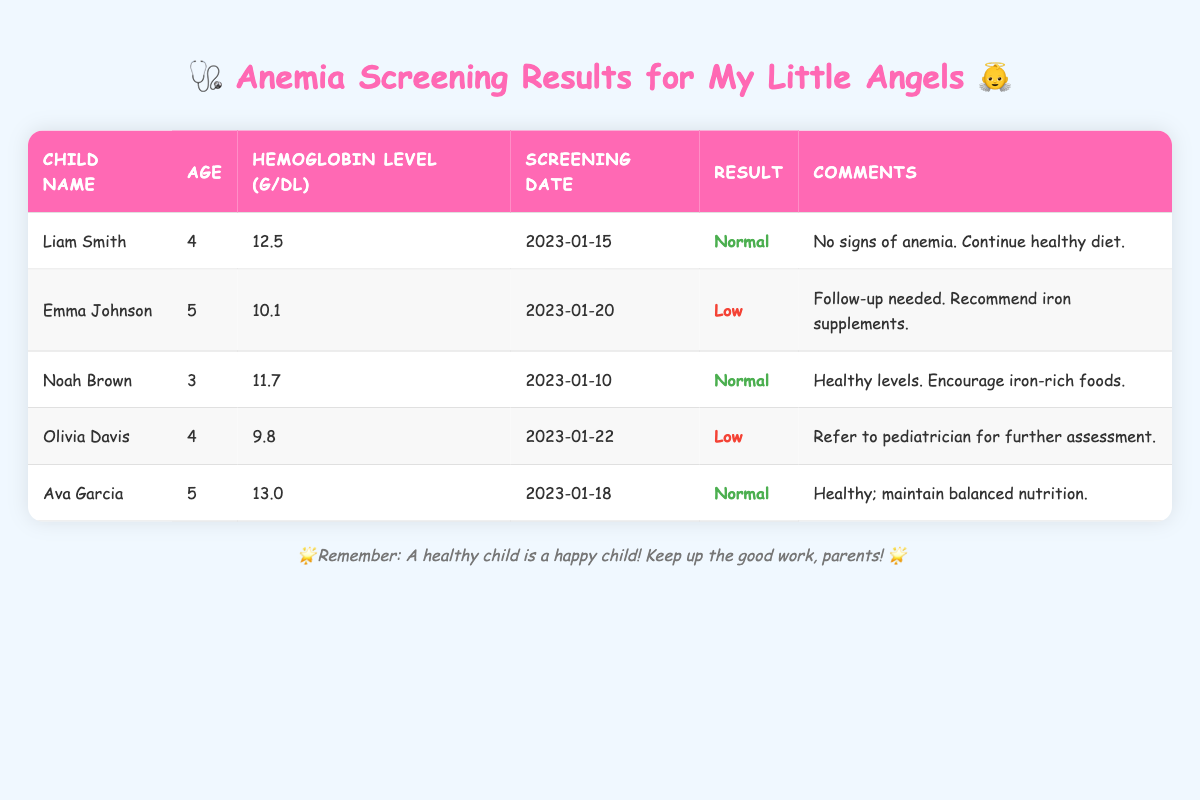What is the hemoglobin level of Emma Johnson? By looking at the row where Emma Johnson's name is listed, we can find her hemoglobin level in the third column, which shows 10.1 g/dL.
Answer: 10.1 g/dL Who has the lowest hemoglobin level among the children? We need to compare the hemoglobin levels of all the children listed. Olivia Davis has the lowest level at 9.8 g/dL when we examine all the entries.
Answer: Olivia Davis How many children have normal hemoglobin levels? By counting the entries with "Normal" in the result column, we find three children: Liam Smith, Noah Brown, and Ava Garcia.
Answer: 3 children What is the average hemoglobin level of the children? First, we sum the hemoglobin levels: 12.5 + 10.1 + 11.7 + 9.8 + 13.0 = 57.1. Then, we divide by the number of children, which is 5. So, the average is 57.1 / 5 = 11.42 g/dL.
Answer: 11.42 g/dL Was there a follow-up recommended for any children? We can check the comments for each child. Both Emma Johnson and Olivia Davis had follow-ups recommended: one for iron supplements and the other for further assessment, respectively.
Answer: Yes What is the age of the child with the highest hemoglobin level? By identifying that Ava Garcia has the highest hemoglobin level at 13.0 g/dL, and her age in the second column is 5 years old, we can answer the question.
Answer: 5 years Do any children require a follow-up consultation? Checking the comments, we see that both Emma Johnson and Olivia Davis are recommended for follow-up consultations; therefore, the answer is based on these observations.
Answer: Yes Which child's result indicates a normal condition? We look for entries with "Normal" in the result column, finding results for Liam Smith, Noah Brown, and Ava Garcia. Hence, the question is answered positively for these children.
Answer: Liam Smith, Noah Brown, Ava Garcia 